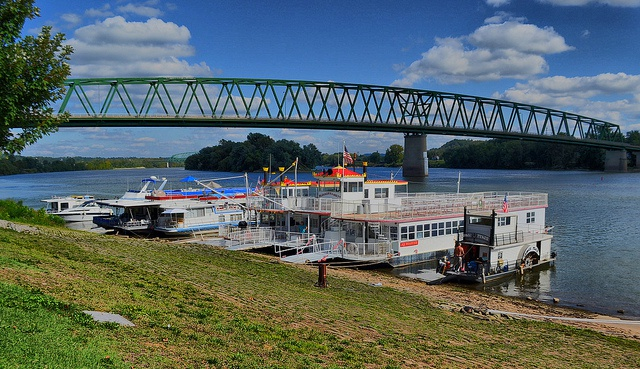Describe the objects in this image and their specific colors. I can see boat in black, darkgray, and gray tones, boat in black, darkgray, gray, and blue tones, boat in black, darkgray, gray, and lightgray tones, boat in black, darkgray, gray, and lightgray tones, and boat in black, darkgray, lightgray, and gray tones in this image. 